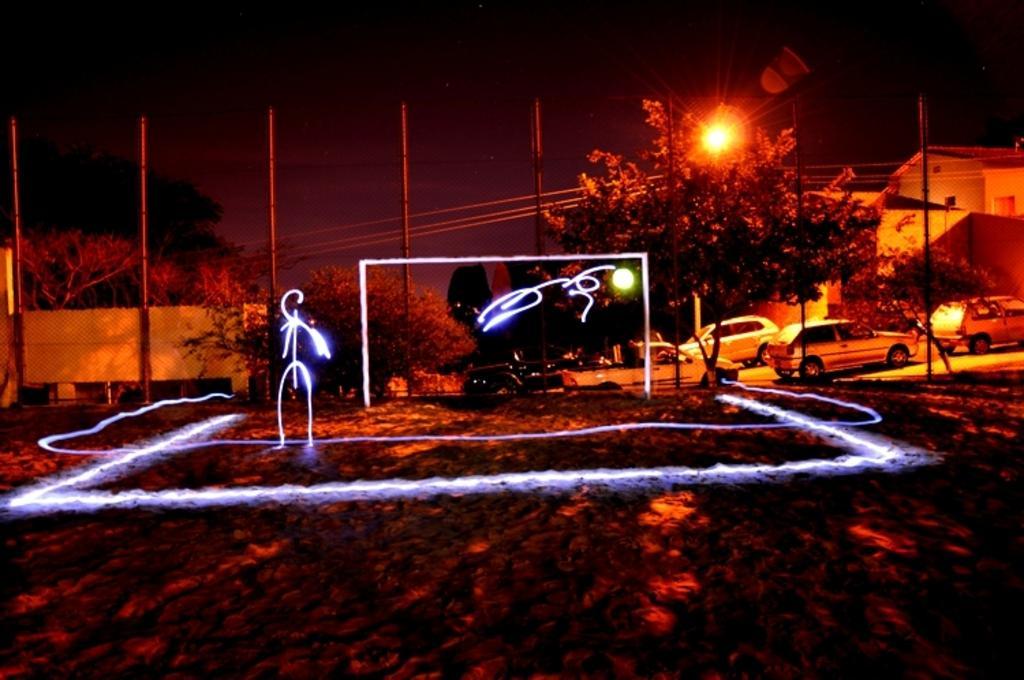Describe this image in one or two sentences. In this image we can see laser lights, trees, poles, building, vehicles, lights, walls and mesh. 